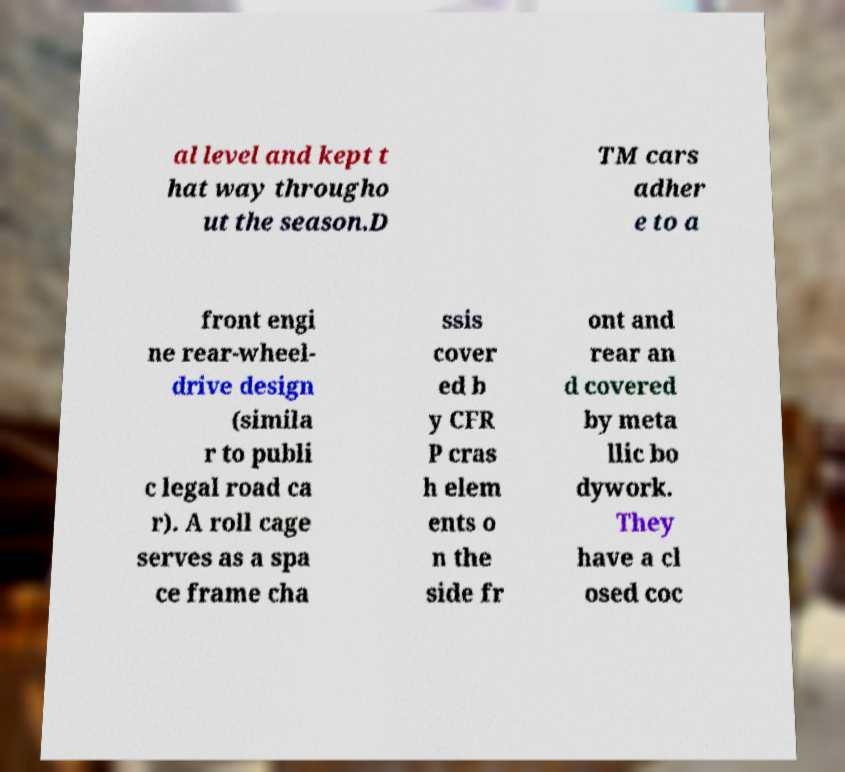Please identify and transcribe the text found in this image. al level and kept t hat way througho ut the season.D TM cars adher e to a front engi ne rear-wheel- drive design (simila r to publi c legal road ca r). A roll cage serves as a spa ce frame cha ssis cover ed b y CFR P cras h elem ents o n the side fr ont and rear an d covered by meta llic bo dywork. They have a cl osed coc 